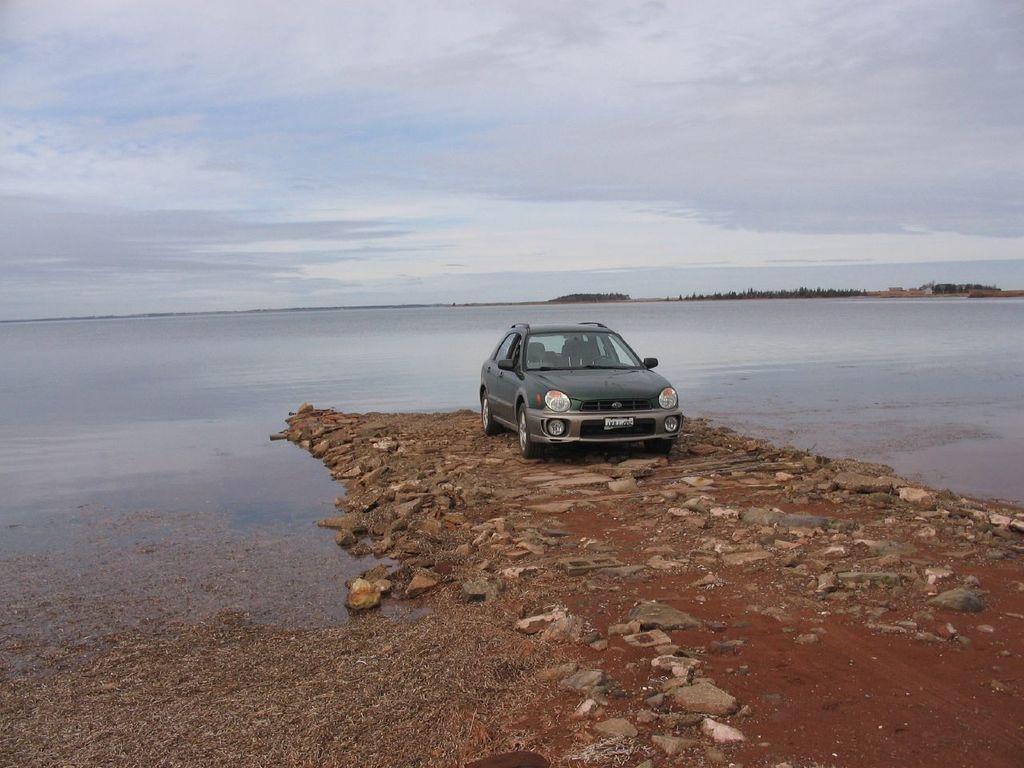Could you give a brief overview of what you see in this image? In this image I can see a car. There is water in the center and there are trees at the back. There is sky at the top. 